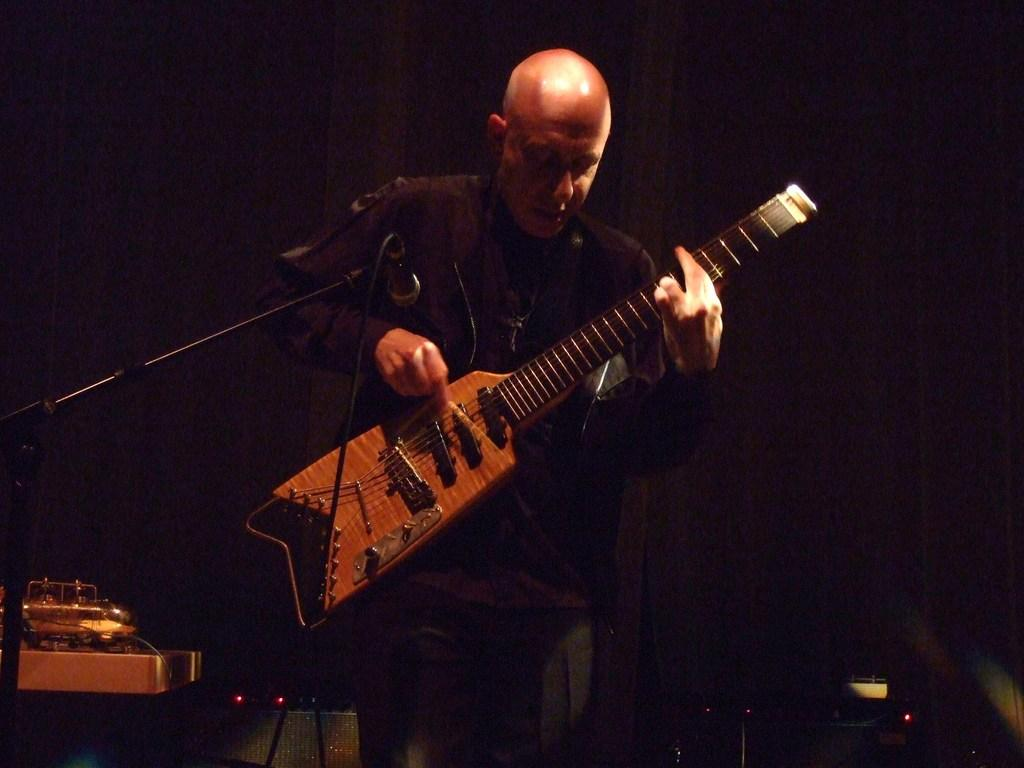What is the man in the image doing? The man is playing the guitar. How is the man positioned in the image? The man is standing. What object is the man holding in the image? The man is holding a guitar. What is the man standing in front of in the image? The man is in front of a microphone. What can be seen on the left side of the image? There are speakers on the left side of the image. Are there any visible wires in the image? Yes, there are wires visible in the image. What type of apple is the man eating while playing the guitar in the image? There is no apple present in the image; the man is playing the guitar without any food. 